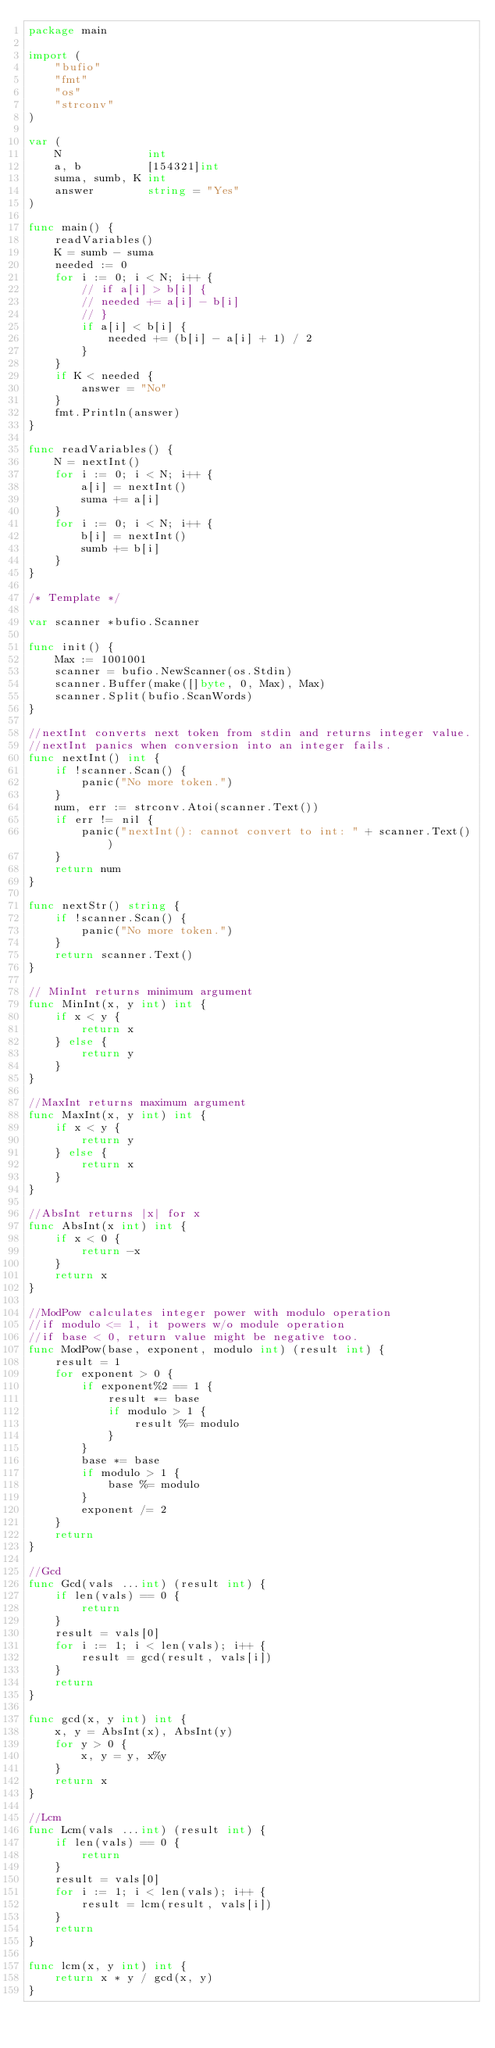Convert code to text. <code><loc_0><loc_0><loc_500><loc_500><_Go_>package main

import (
	"bufio"
	"fmt"
	"os"
	"strconv"
)

var (
	N             int
	a, b          [154321]int
	suma, sumb, K int
	answer        string = "Yes"
)

func main() {
	readVariables()
	K = sumb - suma
	needed := 0
	for i := 0; i < N; i++ {
		// if a[i] > b[i] {
		// needed += a[i] - b[i]
		// }
		if a[i] < b[i] {
			needed += (b[i] - a[i] + 1) / 2
		}
	}
	if K < needed {
		answer = "No"
	}
	fmt.Println(answer)
}

func readVariables() {
	N = nextInt()
	for i := 0; i < N; i++ {
		a[i] = nextInt()
		suma += a[i]
	}
	for i := 0; i < N; i++ {
		b[i] = nextInt()
		sumb += b[i]
	}
}

/* Template */

var scanner *bufio.Scanner

func init() {
	Max := 1001001
	scanner = bufio.NewScanner(os.Stdin)
	scanner.Buffer(make([]byte, 0, Max), Max)
	scanner.Split(bufio.ScanWords)
}

//nextInt converts next token from stdin and returns integer value.
//nextInt panics when conversion into an integer fails.
func nextInt() int {
	if !scanner.Scan() {
		panic("No more token.")
	}
	num, err := strconv.Atoi(scanner.Text())
	if err != nil {
		panic("nextInt(): cannot convert to int: " + scanner.Text())
	}
	return num
}

func nextStr() string {
	if !scanner.Scan() {
		panic("No more token.")
	}
	return scanner.Text()
}

// MinInt returns minimum argument
func MinInt(x, y int) int {
	if x < y {
		return x
	} else {
		return y
	}
}

//MaxInt returns maximum argument
func MaxInt(x, y int) int {
	if x < y {
		return y
	} else {
		return x
	}
}

//AbsInt returns |x| for x
func AbsInt(x int) int {
	if x < 0 {
		return -x
	}
	return x
}

//ModPow calculates integer power with modulo operation
//if modulo <= 1, it powers w/o module operation
//if base < 0, return value might be negative too.
func ModPow(base, exponent, modulo int) (result int) {
	result = 1
	for exponent > 0 {
		if exponent%2 == 1 {
			result *= base
			if modulo > 1 {
				result %= modulo
			}
		}
		base *= base
		if modulo > 1 {
			base %= modulo
		}
		exponent /= 2
	}
	return
}

//Gcd
func Gcd(vals ...int) (result int) {
	if len(vals) == 0 {
		return
	}
	result = vals[0]
	for i := 1; i < len(vals); i++ {
		result = gcd(result, vals[i])
	}
	return
}

func gcd(x, y int) int {
	x, y = AbsInt(x), AbsInt(y)
	for y > 0 {
		x, y = y, x%y
	}
	return x
}

//Lcm
func Lcm(vals ...int) (result int) {
	if len(vals) == 0 {
		return
	}
	result = vals[0]
	for i := 1; i < len(vals); i++ {
		result = lcm(result, vals[i])
	}
	return
}

func lcm(x, y int) int {
	return x * y / gcd(x, y)
}
</code> 